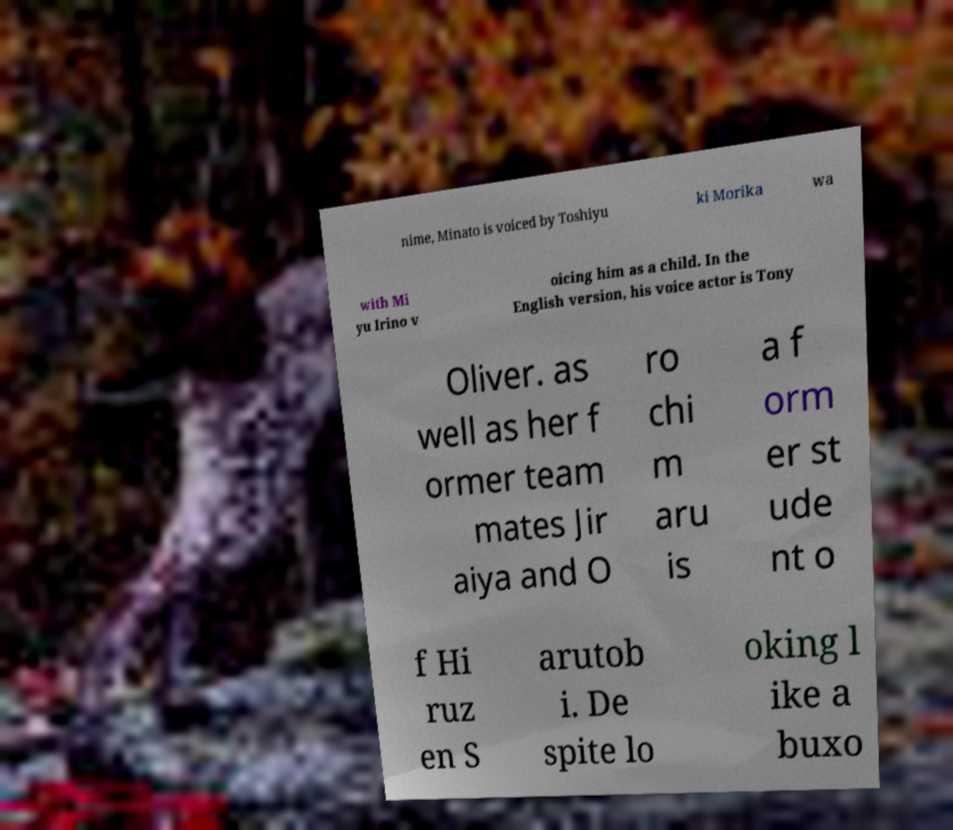There's text embedded in this image that I need extracted. Can you transcribe it verbatim? nime, Minato is voiced by Toshiyu ki Morika wa with Mi yu Irino v oicing him as a child. In the English version, his voice actor is Tony Oliver. as well as her f ormer team mates Jir aiya and O ro chi m aru is a f orm er st ude nt o f Hi ruz en S arutob i. De spite lo oking l ike a buxo 